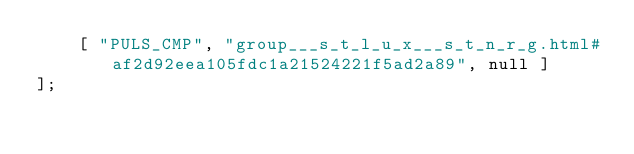Convert code to text. <code><loc_0><loc_0><loc_500><loc_500><_JavaScript_>    [ "PULS_CMP", "group___s_t_l_u_x___s_t_n_r_g.html#af2d92eea105fdc1a21524221f5ad2a89", null ]
];</code> 